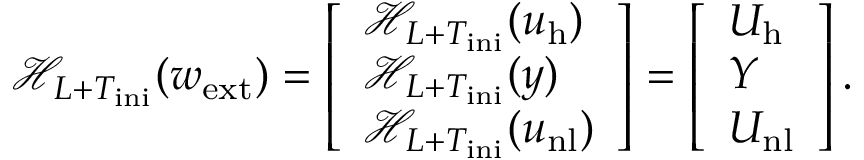Convert formula to latex. <formula><loc_0><loc_0><loc_500><loc_500>\mathcal { H } _ { L + T _ { i n i } } ( w _ { e x t } ) = \left [ \begin{array} { l } { \mathcal { H } _ { L + T _ { i n i } } ( u _ { h } ) } \\ { \mathcal { H } _ { L + T _ { i n i } } ( y ) } \\ { \mathcal { H } _ { L + T _ { i n i } } ( u _ { n l } ) } \end{array} \right ] = \left [ \begin{array} { l } { U _ { h } } \\ { Y } \\ { U _ { n l } } \end{array} \right ] .</formula> 